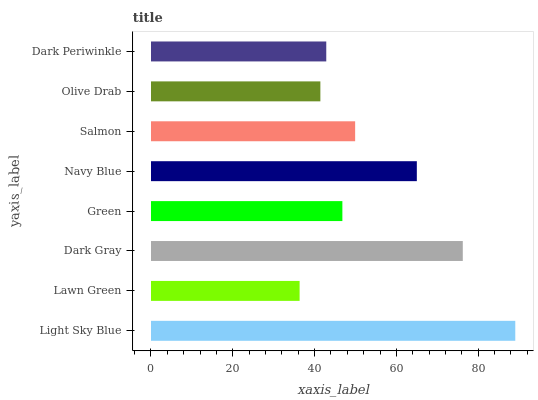Is Lawn Green the minimum?
Answer yes or no. Yes. Is Light Sky Blue the maximum?
Answer yes or no. Yes. Is Dark Gray the minimum?
Answer yes or no. No. Is Dark Gray the maximum?
Answer yes or no. No. Is Dark Gray greater than Lawn Green?
Answer yes or no. Yes. Is Lawn Green less than Dark Gray?
Answer yes or no. Yes. Is Lawn Green greater than Dark Gray?
Answer yes or no. No. Is Dark Gray less than Lawn Green?
Answer yes or no. No. Is Salmon the high median?
Answer yes or no. Yes. Is Green the low median?
Answer yes or no. Yes. Is Lawn Green the high median?
Answer yes or no. No. Is Navy Blue the low median?
Answer yes or no. No. 